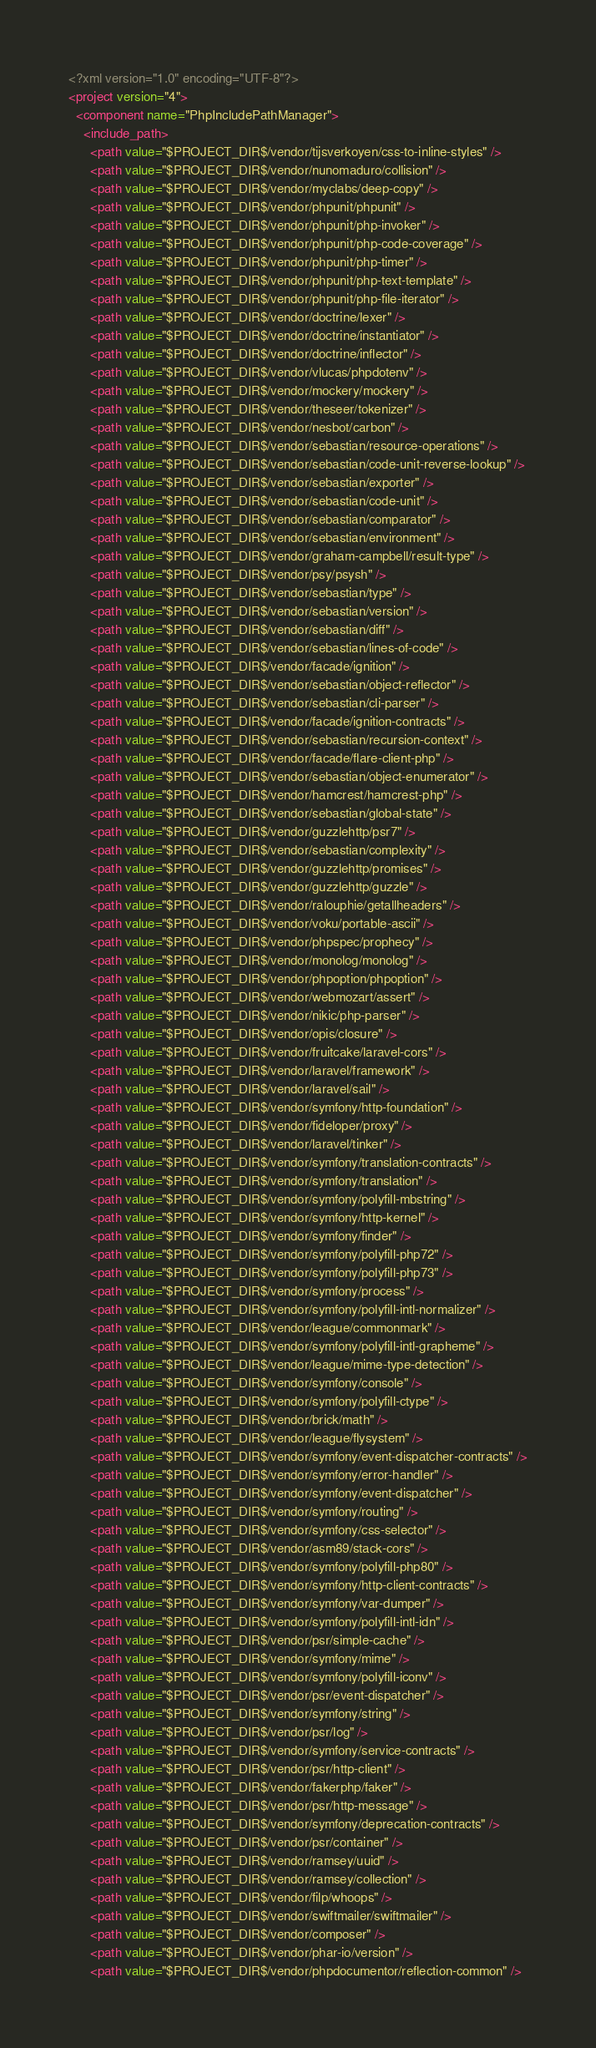Convert code to text. <code><loc_0><loc_0><loc_500><loc_500><_XML_><?xml version="1.0" encoding="UTF-8"?>
<project version="4">
  <component name="PhpIncludePathManager">
    <include_path>
      <path value="$PROJECT_DIR$/vendor/tijsverkoyen/css-to-inline-styles" />
      <path value="$PROJECT_DIR$/vendor/nunomaduro/collision" />
      <path value="$PROJECT_DIR$/vendor/myclabs/deep-copy" />
      <path value="$PROJECT_DIR$/vendor/phpunit/phpunit" />
      <path value="$PROJECT_DIR$/vendor/phpunit/php-invoker" />
      <path value="$PROJECT_DIR$/vendor/phpunit/php-code-coverage" />
      <path value="$PROJECT_DIR$/vendor/phpunit/php-timer" />
      <path value="$PROJECT_DIR$/vendor/phpunit/php-text-template" />
      <path value="$PROJECT_DIR$/vendor/phpunit/php-file-iterator" />
      <path value="$PROJECT_DIR$/vendor/doctrine/lexer" />
      <path value="$PROJECT_DIR$/vendor/doctrine/instantiator" />
      <path value="$PROJECT_DIR$/vendor/doctrine/inflector" />
      <path value="$PROJECT_DIR$/vendor/vlucas/phpdotenv" />
      <path value="$PROJECT_DIR$/vendor/mockery/mockery" />
      <path value="$PROJECT_DIR$/vendor/theseer/tokenizer" />
      <path value="$PROJECT_DIR$/vendor/nesbot/carbon" />
      <path value="$PROJECT_DIR$/vendor/sebastian/resource-operations" />
      <path value="$PROJECT_DIR$/vendor/sebastian/code-unit-reverse-lookup" />
      <path value="$PROJECT_DIR$/vendor/sebastian/exporter" />
      <path value="$PROJECT_DIR$/vendor/sebastian/code-unit" />
      <path value="$PROJECT_DIR$/vendor/sebastian/comparator" />
      <path value="$PROJECT_DIR$/vendor/sebastian/environment" />
      <path value="$PROJECT_DIR$/vendor/graham-campbell/result-type" />
      <path value="$PROJECT_DIR$/vendor/psy/psysh" />
      <path value="$PROJECT_DIR$/vendor/sebastian/type" />
      <path value="$PROJECT_DIR$/vendor/sebastian/version" />
      <path value="$PROJECT_DIR$/vendor/sebastian/diff" />
      <path value="$PROJECT_DIR$/vendor/sebastian/lines-of-code" />
      <path value="$PROJECT_DIR$/vendor/facade/ignition" />
      <path value="$PROJECT_DIR$/vendor/sebastian/object-reflector" />
      <path value="$PROJECT_DIR$/vendor/sebastian/cli-parser" />
      <path value="$PROJECT_DIR$/vendor/facade/ignition-contracts" />
      <path value="$PROJECT_DIR$/vendor/sebastian/recursion-context" />
      <path value="$PROJECT_DIR$/vendor/facade/flare-client-php" />
      <path value="$PROJECT_DIR$/vendor/sebastian/object-enumerator" />
      <path value="$PROJECT_DIR$/vendor/hamcrest/hamcrest-php" />
      <path value="$PROJECT_DIR$/vendor/sebastian/global-state" />
      <path value="$PROJECT_DIR$/vendor/guzzlehttp/psr7" />
      <path value="$PROJECT_DIR$/vendor/sebastian/complexity" />
      <path value="$PROJECT_DIR$/vendor/guzzlehttp/promises" />
      <path value="$PROJECT_DIR$/vendor/guzzlehttp/guzzle" />
      <path value="$PROJECT_DIR$/vendor/ralouphie/getallheaders" />
      <path value="$PROJECT_DIR$/vendor/voku/portable-ascii" />
      <path value="$PROJECT_DIR$/vendor/phpspec/prophecy" />
      <path value="$PROJECT_DIR$/vendor/monolog/monolog" />
      <path value="$PROJECT_DIR$/vendor/phpoption/phpoption" />
      <path value="$PROJECT_DIR$/vendor/webmozart/assert" />
      <path value="$PROJECT_DIR$/vendor/nikic/php-parser" />
      <path value="$PROJECT_DIR$/vendor/opis/closure" />
      <path value="$PROJECT_DIR$/vendor/fruitcake/laravel-cors" />
      <path value="$PROJECT_DIR$/vendor/laravel/framework" />
      <path value="$PROJECT_DIR$/vendor/laravel/sail" />
      <path value="$PROJECT_DIR$/vendor/symfony/http-foundation" />
      <path value="$PROJECT_DIR$/vendor/fideloper/proxy" />
      <path value="$PROJECT_DIR$/vendor/laravel/tinker" />
      <path value="$PROJECT_DIR$/vendor/symfony/translation-contracts" />
      <path value="$PROJECT_DIR$/vendor/symfony/translation" />
      <path value="$PROJECT_DIR$/vendor/symfony/polyfill-mbstring" />
      <path value="$PROJECT_DIR$/vendor/symfony/http-kernel" />
      <path value="$PROJECT_DIR$/vendor/symfony/finder" />
      <path value="$PROJECT_DIR$/vendor/symfony/polyfill-php72" />
      <path value="$PROJECT_DIR$/vendor/symfony/polyfill-php73" />
      <path value="$PROJECT_DIR$/vendor/symfony/process" />
      <path value="$PROJECT_DIR$/vendor/symfony/polyfill-intl-normalizer" />
      <path value="$PROJECT_DIR$/vendor/league/commonmark" />
      <path value="$PROJECT_DIR$/vendor/symfony/polyfill-intl-grapheme" />
      <path value="$PROJECT_DIR$/vendor/league/mime-type-detection" />
      <path value="$PROJECT_DIR$/vendor/symfony/console" />
      <path value="$PROJECT_DIR$/vendor/symfony/polyfill-ctype" />
      <path value="$PROJECT_DIR$/vendor/brick/math" />
      <path value="$PROJECT_DIR$/vendor/league/flysystem" />
      <path value="$PROJECT_DIR$/vendor/symfony/event-dispatcher-contracts" />
      <path value="$PROJECT_DIR$/vendor/symfony/error-handler" />
      <path value="$PROJECT_DIR$/vendor/symfony/event-dispatcher" />
      <path value="$PROJECT_DIR$/vendor/symfony/routing" />
      <path value="$PROJECT_DIR$/vendor/symfony/css-selector" />
      <path value="$PROJECT_DIR$/vendor/asm89/stack-cors" />
      <path value="$PROJECT_DIR$/vendor/symfony/polyfill-php80" />
      <path value="$PROJECT_DIR$/vendor/symfony/http-client-contracts" />
      <path value="$PROJECT_DIR$/vendor/symfony/var-dumper" />
      <path value="$PROJECT_DIR$/vendor/symfony/polyfill-intl-idn" />
      <path value="$PROJECT_DIR$/vendor/psr/simple-cache" />
      <path value="$PROJECT_DIR$/vendor/symfony/mime" />
      <path value="$PROJECT_DIR$/vendor/symfony/polyfill-iconv" />
      <path value="$PROJECT_DIR$/vendor/psr/event-dispatcher" />
      <path value="$PROJECT_DIR$/vendor/symfony/string" />
      <path value="$PROJECT_DIR$/vendor/psr/log" />
      <path value="$PROJECT_DIR$/vendor/symfony/service-contracts" />
      <path value="$PROJECT_DIR$/vendor/psr/http-client" />
      <path value="$PROJECT_DIR$/vendor/fakerphp/faker" />
      <path value="$PROJECT_DIR$/vendor/psr/http-message" />
      <path value="$PROJECT_DIR$/vendor/symfony/deprecation-contracts" />
      <path value="$PROJECT_DIR$/vendor/psr/container" />
      <path value="$PROJECT_DIR$/vendor/ramsey/uuid" />
      <path value="$PROJECT_DIR$/vendor/ramsey/collection" />
      <path value="$PROJECT_DIR$/vendor/filp/whoops" />
      <path value="$PROJECT_DIR$/vendor/swiftmailer/swiftmailer" />
      <path value="$PROJECT_DIR$/vendor/composer" />
      <path value="$PROJECT_DIR$/vendor/phar-io/version" />
      <path value="$PROJECT_DIR$/vendor/phpdocumentor/reflection-common" /></code> 